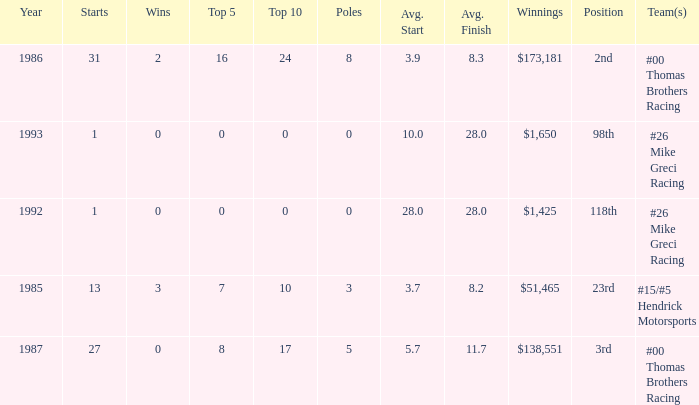What position did he finish in 1987? 3rd. 